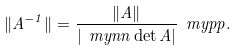<formula> <loc_0><loc_0><loc_500><loc_500>\| A ^ { - 1 } \| = \frac { \| A \| } { | \ m y n n \det A | } \ m y p p .</formula> 